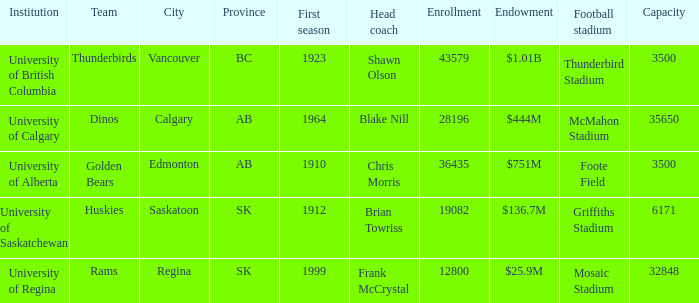What football arena has a student population of 43579? Thunderbird Stadium. 